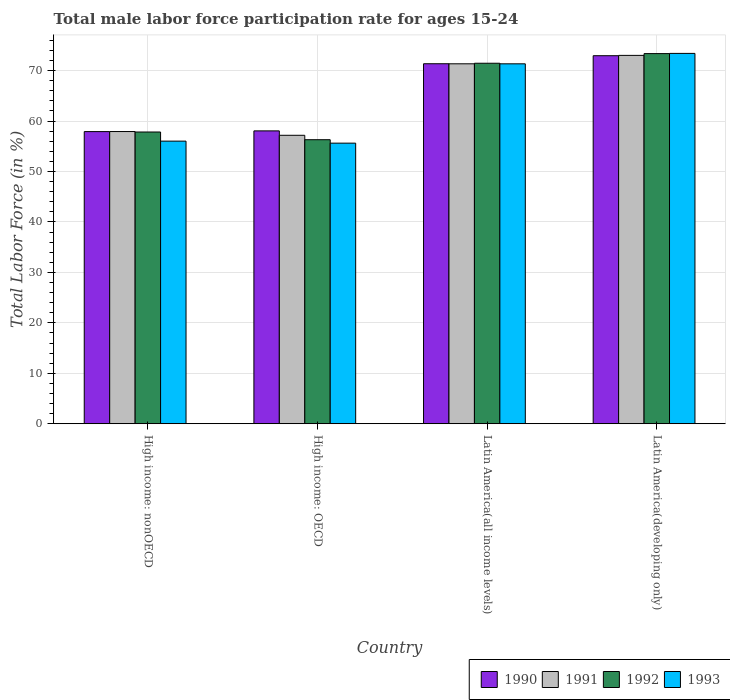Are the number of bars per tick equal to the number of legend labels?
Provide a succinct answer. Yes. How many bars are there on the 2nd tick from the left?
Give a very brief answer. 4. What is the label of the 3rd group of bars from the left?
Keep it short and to the point. Latin America(all income levels). What is the male labor force participation rate in 1990 in Latin America(developing only)?
Provide a succinct answer. 72.96. Across all countries, what is the maximum male labor force participation rate in 1990?
Provide a short and direct response. 72.96. Across all countries, what is the minimum male labor force participation rate in 1993?
Your answer should be compact. 55.62. In which country was the male labor force participation rate in 1990 maximum?
Offer a terse response. Latin America(developing only). In which country was the male labor force participation rate in 1992 minimum?
Make the answer very short. High income: OECD. What is the total male labor force participation rate in 1991 in the graph?
Offer a terse response. 259.48. What is the difference between the male labor force participation rate in 1990 in Latin America(all income levels) and that in Latin America(developing only)?
Provide a succinct answer. -1.59. What is the difference between the male labor force participation rate in 1991 in High income: nonOECD and the male labor force participation rate in 1992 in Latin America(developing only)?
Your answer should be compact. -15.45. What is the average male labor force participation rate in 1991 per country?
Give a very brief answer. 64.87. What is the difference between the male labor force participation rate of/in 1993 and male labor force participation rate of/in 1990 in High income: nonOECD?
Make the answer very short. -1.89. What is the ratio of the male labor force participation rate in 1990 in High income: OECD to that in Latin America(all income levels)?
Offer a terse response. 0.81. What is the difference between the highest and the second highest male labor force participation rate in 1990?
Keep it short and to the point. 14.9. What is the difference between the highest and the lowest male labor force participation rate in 1991?
Your response must be concise. 15.84. Is the sum of the male labor force participation rate in 1991 in Latin America(all income levels) and Latin America(developing only) greater than the maximum male labor force participation rate in 1990 across all countries?
Offer a terse response. Yes. Is it the case that in every country, the sum of the male labor force participation rate in 1993 and male labor force participation rate in 1992 is greater than the male labor force participation rate in 1991?
Offer a very short reply. Yes. How many bars are there?
Your answer should be compact. 16. Are all the bars in the graph horizontal?
Your answer should be compact. No. What is the difference between two consecutive major ticks on the Y-axis?
Your response must be concise. 10. Are the values on the major ticks of Y-axis written in scientific E-notation?
Ensure brevity in your answer.  No. Does the graph contain grids?
Provide a short and direct response. Yes. How many legend labels are there?
Your answer should be very brief. 4. How are the legend labels stacked?
Provide a short and direct response. Horizontal. What is the title of the graph?
Ensure brevity in your answer.  Total male labor force participation rate for ages 15-24. Does "1998" appear as one of the legend labels in the graph?
Offer a very short reply. No. What is the label or title of the X-axis?
Make the answer very short. Country. What is the Total Labor Force (in %) of 1990 in High income: nonOECD?
Your answer should be very brief. 57.91. What is the Total Labor Force (in %) of 1991 in High income: nonOECD?
Your answer should be compact. 57.92. What is the Total Labor Force (in %) in 1992 in High income: nonOECD?
Provide a short and direct response. 57.83. What is the Total Labor Force (in %) of 1993 in High income: nonOECD?
Offer a terse response. 56.02. What is the Total Labor Force (in %) of 1990 in High income: OECD?
Your answer should be very brief. 58.06. What is the Total Labor Force (in %) of 1991 in High income: OECD?
Provide a short and direct response. 57.18. What is the Total Labor Force (in %) of 1992 in High income: OECD?
Offer a very short reply. 56.31. What is the Total Labor Force (in %) of 1993 in High income: OECD?
Offer a terse response. 55.62. What is the Total Labor Force (in %) of 1990 in Latin America(all income levels)?
Your response must be concise. 71.36. What is the Total Labor Force (in %) in 1991 in Latin America(all income levels)?
Provide a short and direct response. 71.35. What is the Total Labor Force (in %) of 1992 in Latin America(all income levels)?
Make the answer very short. 71.46. What is the Total Labor Force (in %) of 1993 in Latin America(all income levels)?
Give a very brief answer. 71.35. What is the Total Labor Force (in %) in 1990 in Latin America(developing only)?
Keep it short and to the point. 72.96. What is the Total Labor Force (in %) of 1991 in Latin America(developing only)?
Your response must be concise. 73.02. What is the Total Labor Force (in %) in 1992 in Latin America(developing only)?
Make the answer very short. 73.38. What is the Total Labor Force (in %) of 1993 in Latin America(developing only)?
Your response must be concise. 73.42. Across all countries, what is the maximum Total Labor Force (in %) in 1990?
Ensure brevity in your answer.  72.96. Across all countries, what is the maximum Total Labor Force (in %) in 1991?
Offer a very short reply. 73.02. Across all countries, what is the maximum Total Labor Force (in %) in 1992?
Provide a succinct answer. 73.38. Across all countries, what is the maximum Total Labor Force (in %) in 1993?
Your answer should be very brief. 73.42. Across all countries, what is the minimum Total Labor Force (in %) in 1990?
Ensure brevity in your answer.  57.91. Across all countries, what is the minimum Total Labor Force (in %) in 1991?
Keep it short and to the point. 57.18. Across all countries, what is the minimum Total Labor Force (in %) in 1992?
Ensure brevity in your answer.  56.31. Across all countries, what is the minimum Total Labor Force (in %) in 1993?
Offer a terse response. 55.62. What is the total Total Labor Force (in %) of 1990 in the graph?
Provide a succinct answer. 260.29. What is the total Total Labor Force (in %) in 1991 in the graph?
Make the answer very short. 259.48. What is the total Total Labor Force (in %) in 1992 in the graph?
Make the answer very short. 258.98. What is the total Total Labor Force (in %) of 1993 in the graph?
Give a very brief answer. 256.41. What is the difference between the Total Labor Force (in %) of 1990 in High income: nonOECD and that in High income: OECD?
Make the answer very short. -0.14. What is the difference between the Total Labor Force (in %) of 1991 in High income: nonOECD and that in High income: OECD?
Your answer should be very brief. 0.74. What is the difference between the Total Labor Force (in %) of 1992 in High income: nonOECD and that in High income: OECD?
Your response must be concise. 1.53. What is the difference between the Total Labor Force (in %) of 1993 in High income: nonOECD and that in High income: OECD?
Your answer should be compact. 0.4. What is the difference between the Total Labor Force (in %) of 1990 in High income: nonOECD and that in Latin America(all income levels)?
Offer a very short reply. -13.45. What is the difference between the Total Labor Force (in %) of 1991 in High income: nonOECD and that in Latin America(all income levels)?
Your answer should be very brief. -13.43. What is the difference between the Total Labor Force (in %) in 1992 in High income: nonOECD and that in Latin America(all income levels)?
Your answer should be compact. -13.63. What is the difference between the Total Labor Force (in %) of 1993 in High income: nonOECD and that in Latin America(all income levels)?
Your answer should be compact. -15.33. What is the difference between the Total Labor Force (in %) in 1990 in High income: nonOECD and that in Latin America(developing only)?
Provide a short and direct response. -15.05. What is the difference between the Total Labor Force (in %) in 1991 in High income: nonOECD and that in Latin America(developing only)?
Keep it short and to the point. -15.1. What is the difference between the Total Labor Force (in %) in 1992 in High income: nonOECD and that in Latin America(developing only)?
Your answer should be compact. -15.54. What is the difference between the Total Labor Force (in %) of 1993 in High income: nonOECD and that in Latin America(developing only)?
Provide a succinct answer. -17.39. What is the difference between the Total Labor Force (in %) in 1990 in High income: OECD and that in Latin America(all income levels)?
Offer a terse response. -13.31. What is the difference between the Total Labor Force (in %) in 1991 in High income: OECD and that in Latin America(all income levels)?
Give a very brief answer. -14.17. What is the difference between the Total Labor Force (in %) of 1992 in High income: OECD and that in Latin America(all income levels)?
Give a very brief answer. -15.16. What is the difference between the Total Labor Force (in %) of 1993 in High income: OECD and that in Latin America(all income levels)?
Your answer should be compact. -15.73. What is the difference between the Total Labor Force (in %) of 1990 in High income: OECD and that in Latin America(developing only)?
Give a very brief answer. -14.9. What is the difference between the Total Labor Force (in %) in 1991 in High income: OECD and that in Latin America(developing only)?
Your response must be concise. -15.84. What is the difference between the Total Labor Force (in %) in 1992 in High income: OECD and that in Latin America(developing only)?
Your response must be concise. -17.07. What is the difference between the Total Labor Force (in %) in 1993 in High income: OECD and that in Latin America(developing only)?
Provide a short and direct response. -17.79. What is the difference between the Total Labor Force (in %) of 1990 in Latin America(all income levels) and that in Latin America(developing only)?
Your answer should be very brief. -1.59. What is the difference between the Total Labor Force (in %) in 1991 in Latin America(all income levels) and that in Latin America(developing only)?
Keep it short and to the point. -1.67. What is the difference between the Total Labor Force (in %) in 1992 in Latin America(all income levels) and that in Latin America(developing only)?
Provide a succinct answer. -1.91. What is the difference between the Total Labor Force (in %) of 1993 in Latin America(all income levels) and that in Latin America(developing only)?
Give a very brief answer. -2.07. What is the difference between the Total Labor Force (in %) of 1990 in High income: nonOECD and the Total Labor Force (in %) of 1991 in High income: OECD?
Provide a succinct answer. 0.73. What is the difference between the Total Labor Force (in %) of 1990 in High income: nonOECD and the Total Labor Force (in %) of 1992 in High income: OECD?
Provide a short and direct response. 1.61. What is the difference between the Total Labor Force (in %) in 1990 in High income: nonOECD and the Total Labor Force (in %) in 1993 in High income: OECD?
Keep it short and to the point. 2.29. What is the difference between the Total Labor Force (in %) in 1991 in High income: nonOECD and the Total Labor Force (in %) in 1992 in High income: OECD?
Offer a terse response. 1.62. What is the difference between the Total Labor Force (in %) of 1991 in High income: nonOECD and the Total Labor Force (in %) of 1993 in High income: OECD?
Your answer should be compact. 2.3. What is the difference between the Total Labor Force (in %) of 1992 in High income: nonOECD and the Total Labor Force (in %) of 1993 in High income: OECD?
Your answer should be very brief. 2.21. What is the difference between the Total Labor Force (in %) in 1990 in High income: nonOECD and the Total Labor Force (in %) in 1991 in Latin America(all income levels)?
Make the answer very short. -13.44. What is the difference between the Total Labor Force (in %) in 1990 in High income: nonOECD and the Total Labor Force (in %) in 1992 in Latin America(all income levels)?
Give a very brief answer. -13.55. What is the difference between the Total Labor Force (in %) in 1990 in High income: nonOECD and the Total Labor Force (in %) in 1993 in Latin America(all income levels)?
Your answer should be very brief. -13.44. What is the difference between the Total Labor Force (in %) of 1991 in High income: nonOECD and the Total Labor Force (in %) of 1992 in Latin America(all income levels)?
Your answer should be compact. -13.54. What is the difference between the Total Labor Force (in %) of 1991 in High income: nonOECD and the Total Labor Force (in %) of 1993 in Latin America(all income levels)?
Your answer should be very brief. -13.43. What is the difference between the Total Labor Force (in %) of 1992 in High income: nonOECD and the Total Labor Force (in %) of 1993 in Latin America(all income levels)?
Your response must be concise. -13.52. What is the difference between the Total Labor Force (in %) of 1990 in High income: nonOECD and the Total Labor Force (in %) of 1991 in Latin America(developing only)?
Make the answer very short. -15.11. What is the difference between the Total Labor Force (in %) in 1990 in High income: nonOECD and the Total Labor Force (in %) in 1992 in Latin America(developing only)?
Provide a succinct answer. -15.46. What is the difference between the Total Labor Force (in %) of 1990 in High income: nonOECD and the Total Labor Force (in %) of 1993 in Latin America(developing only)?
Ensure brevity in your answer.  -15.5. What is the difference between the Total Labor Force (in %) in 1991 in High income: nonOECD and the Total Labor Force (in %) in 1992 in Latin America(developing only)?
Offer a very short reply. -15.45. What is the difference between the Total Labor Force (in %) in 1991 in High income: nonOECD and the Total Labor Force (in %) in 1993 in Latin America(developing only)?
Provide a short and direct response. -15.49. What is the difference between the Total Labor Force (in %) in 1992 in High income: nonOECD and the Total Labor Force (in %) in 1993 in Latin America(developing only)?
Ensure brevity in your answer.  -15.59. What is the difference between the Total Labor Force (in %) of 1990 in High income: OECD and the Total Labor Force (in %) of 1991 in Latin America(all income levels)?
Provide a succinct answer. -13.3. What is the difference between the Total Labor Force (in %) in 1990 in High income: OECD and the Total Labor Force (in %) in 1992 in Latin America(all income levels)?
Ensure brevity in your answer.  -13.41. What is the difference between the Total Labor Force (in %) of 1990 in High income: OECD and the Total Labor Force (in %) of 1993 in Latin America(all income levels)?
Offer a very short reply. -13.29. What is the difference between the Total Labor Force (in %) of 1991 in High income: OECD and the Total Labor Force (in %) of 1992 in Latin America(all income levels)?
Make the answer very short. -14.28. What is the difference between the Total Labor Force (in %) in 1991 in High income: OECD and the Total Labor Force (in %) in 1993 in Latin America(all income levels)?
Provide a succinct answer. -14.17. What is the difference between the Total Labor Force (in %) of 1992 in High income: OECD and the Total Labor Force (in %) of 1993 in Latin America(all income levels)?
Offer a terse response. -15.04. What is the difference between the Total Labor Force (in %) in 1990 in High income: OECD and the Total Labor Force (in %) in 1991 in Latin America(developing only)?
Your response must be concise. -14.97. What is the difference between the Total Labor Force (in %) in 1990 in High income: OECD and the Total Labor Force (in %) in 1992 in Latin America(developing only)?
Provide a succinct answer. -15.32. What is the difference between the Total Labor Force (in %) of 1990 in High income: OECD and the Total Labor Force (in %) of 1993 in Latin America(developing only)?
Offer a terse response. -15.36. What is the difference between the Total Labor Force (in %) of 1991 in High income: OECD and the Total Labor Force (in %) of 1992 in Latin America(developing only)?
Your response must be concise. -16.19. What is the difference between the Total Labor Force (in %) in 1991 in High income: OECD and the Total Labor Force (in %) in 1993 in Latin America(developing only)?
Provide a short and direct response. -16.23. What is the difference between the Total Labor Force (in %) of 1992 in High income: OECD and the Total Labor Force (in %) of 1993 in Latin America(developing only)?
Provide a short and direct response. -17.11. What is the difference between the Total Labor Force (in %) of 1990 in Latin America(all income levels) and the Total Labor Force (in %) of 1991 in Latin America(developing only)?
Ensure brevity in your answer.  -1.66. What is the difference between the Total Labor Force (in %) in 1990 in Latin America(all income levels) and the Total Labor Force (in %) in 1992 in Latin America(developing only)?
Offer a very short reply. -2.01. What is the difference between the Total Labor Force (in %) of 1990 in Latin America(all income levels) and the Total Labor Force (in %) of 1993 in Latin America(developing only)?
Your answer should be very brief. -2.05. What is the difference between the Total Labor Force (in %) of 1991 in Latin America(all income levels) and the Total Labor Force (in %) of 1992 in Latin America(developing only)?
Make the answer very short. -2.02. What is the difference between the Total Labor Force (in %) in 1991 in Latin America(all income levels) and the Total Labor Force (in %) in 1993 in Latin America(developing only)?
Provide a short and direct response. -2.06. What is the difference between the Total Labor Force (in %) of 1992 in Latin America(all income levels) and the Total Labor Force (in %) of 1993 in Latin America(developing only)?
Offer a very short reply. -1.95. What is the average Total Labor Force (in %) in 1990 per country?
Offer a terse response. 65.07. What is the average Total Labor Force (in %) in 1991 per country?
Your response must be concise. 64.87. What is the average Total Labor Force (in %) of 1992 per country?
Offer a terse response. 64.74. What is the average Total Labor Force (in %) in 1993 per country?
Keep it short and to the point. 64.1. What is the difference between the Total Labor Force (in %) of 1990 and Total Labor Force (in %) of 1991 in High income: nonOECD?
Your answer should be compact. -0.01. What is the difference between the Total Labor Force (in %) in 1990 and Total Labor Force (in %) in 1992 in High income: nonOECD?
Provide a short and direct response. 0.08. What is the difference between the Total Labor Force (in %) of 1990 and Total Labor Force (in %) of 1993 in High income: nonOECD?
Keep it short and to the point. 1.89. What is the difference between the Total Labor Force (in %) in 1991 and Total Labor Force (in %) in 1992 in High income: nonOECD?
Give a very brief answer. 0.09. What is the difference between the Total Labor Force (in %) in 1991 and Total Labor Force (in %) in 1993 in High income: nonOECD?
Provide a short and direct response. 1.9. What is the difference between the Total Labor Force (in %) of 1992 and Total Labor Force (in %) of 1993 in High income: nonOECD?
Provide a short and direct response. 1.81. What is the difference between the Total Labor Force (in %) in 1990 and Total Labor Force (in %) in 1991 in High income: OECD?
Your response must be concise. 0.87. What is the difference between the Total Labor Force (in %) of 1990 and Total Labor Force (in %) of 1992 in High income: OECD?
Your answer should be compact. 1.75. What is the difference between the Total Labor Force (in %) of 1990 and Total Labor Force (in %) of 1993 in High income: OECD?
Provide a short and direct response. 2.43. What is the difference between the Total Labor Force (in %) in 1991 and Total Labor Force (in %) in 1992 in High income: OECD?
Provide a succinct answer. 0.88. What is the difference between the Total Labor Force (in %) in 1991 and Total Labor Force (in %) in 1993 in High income: OECD?
Give a very brief answer. 1.56. What is the difference between the Total Labor Force (in %) in 1992 and Total Labor Force (in %) in 1993 in High income: OECD?
Make the answer very short. 0.68. What is the difference between the Total Labor Force (in %) of 1990 and Total Labor Force (in %) of 1991 in Latin America(all income levels)?
Provide a short and direct response. 0.01. What is the difference between the Total Labor Force (in %) in 1990 and Total Labor Force (in %) in 1992 in Latin America(all income levels)?
Provide a succinct answer. -0.1. What is the difference between the Total Labor Force (in %) of 1990 and Total Labor Force (in %) of 1993 in Latin America(all income levels)?
Your response must be concise. 0.02. What is the difference between the Total Labor Force (in %) of 1991 and Total Labor Force (in %) of 1992 in Latin America(all income levels)?
Offer a terse response. -0.11. What is the difference between the Total Labor Force (in %) in 1991 and Total Labor Force (in %) in 1993 in Latin America(all income levels)?
Your response must be concise. 0. What is the difference between the Total Labor Force (in %) of 1992 and Total Labor Force (in %) of 1993 in Latin America(all income levels)?
Your response must be concise. 0.11. What is the difference between the Total Labor Force (in %) of 1990 and Total Labor Force (in %) of 1991 in Latin America(developing only)?
Ensure brevity in your answer.  -0.07. What is the difference between the Total Labor Force (in %) in 1990 and Total Labor Force (in %) in 1992 in Latin America(developing only)?
Offer a terse response. -0.42. What is the difference between the Total Labor Force (in %) in 1990 and Total Labor Force (in %) in 1993 in Latin America(developing only)?
Offer a very short reply. -0.46. What is the difference between the Total Labor Force (in %) in 1991 and Total Labor Force (in %) in 1992 in Latin America(developing only)?
Offer a very short reply. -0.35. What is the difference between the Total Labor Force (in %) in 1991 and Total Labor Force (in %) in 1993 in Latin America(developing only)?
Ensure brevity in your answer.  -0.39. What is the difference between the Total Labor Force (in %) in 1992 and Total Labor Force (in %) in 1993 in Latin America(developing only)?
Your answer should be compact. -0.04. What is the ratio of the Total Labor Force (in %) in 1991 in High income: nonOECD to that in High income: OECD?
Provide a succinct answer. 1.01. What is the ratio of the Total Labor Force (in %) of 1992 in High income: nonOECD to that in High income: OECD?
Your response must be concise. 1.03. What is the ratio of the Total Labor Force (in %) of 1993 in High income: nonOECD to that in High income: OECD?
Offer a very short reply. 1.01. What is the ratio of the Total Labor Force (in %) in 1990 in High income: nonOECD to that in Latin America(all income levels)?
Give a very brief answer. 0.81. What is the ratio of the Total Labor Force (in %) of 1991 in High income: nonOECD to that in Latin America(all income levels)?
Make the answer very short. 0.81. What is the ratio of the Total Labor Force (in %) of 1992 in High income: nonOECD to that in Latin America(all income levels)?
Give a very brief answer. 0.81. What is the ratio of the Total Labor Force (in %) of 1993 in High income: nonOECD to that in Latin America(all income levels)?
Provide a short and direct response. 0.79. What is the ratio of the Total Labor Force (in %) of 1990 in High income: nonOECD to that in Latin America(developing only)?
Offer a terse response. 0.79. What is the ratio of the Total Labor Force (in %) of 1991 in High income: nonOECD to that in Latin America(developing only)?
Provide a succinct answer. 0.79. What is the ratio of the Total Labor Force (in %) of 1992 in High income: nonOECD to that in Latin America(developing only)?
Keep it short and to the point. 0.79. What is the ratio of the Total Labor Force (in %) of 1993 in High income: nonOECD to that in Latin America(developing only)?
Provide a succinct answer. 0.76. What is the ratio of the Total Labor Force (in %) of 1990 in High income: OECD to that in Latin America(all income levels)?
Keep it short and to the point. 0.81. What is the ratio of the Total Labor Force (in %) of 1991 in High income: OECD to that in Latin America(all income levels)?
Keep it short and to the point. 0.8. What is the ratio of the Total Labor Force (in %) of 1992 in High income: OECD to that in Latin America(all income levels)?
Keep it short and to the point. 0.79. What is the ratio of the Total Labor Force (in %) in 1993 in High income: OECD to that in Latin America(all income levels)?
Give a very brief answer. 0.78. What is the ratio of the Total Labor Force (in %) in 1990 in High income: OECD to that in Latin America(developing only)?
Your response must be concise. 0.8. What is the ratio of the Total Labor Force (in %) of 1991 in High income: OECD to that in Latin America(developing only)?
Your answer should be compact. 0.78. What is the ratio of the Total Labor Force (in %) in 1992 in High income: OECD to that in Latin America(developing only)?
Your response must be concise. 0.77. What is the ratio of the Total Labor Force (in %) in 1993 in High income: OECD to that in Latin America(developing only)?
Give a very brief answer. 0.76. What is the ratio of the Total Labor Force (in %) in 1990 in Latin America(all income levels) to that in Latin America(developing only)?
Your answer should be very brief. 0.98. What is the ratio of the Total Labor Force (in %) in 1991 in Latin America(all income levels) to that in Latin America(developing only)?
Provide a short and direct response. 0.98. What is the ratio of the Total Labor Force (in %) of 1992 in Latin America(all income levels) to that in Latin America(developing only)?
Give a very brief answer. 0.97. What is the ratio of the Total Labor Force (in %) of 1993 in Latin America(all income levels) to that in Latin America(developing only)?
Offer a very short reply. 0.97. What is the difference between the highest and the second highest Total Labor Force (in %) of 1990?
Keep it short and to the point. 1.59. What is the difference between the highest and the second highest Total Labor Force (in %) in 1991?
Give a very brief answer. 1.67. What is the difference between the highest and the second highest Total Labor Force (in %) of 1992?
Your response must be concise. 1.91. What is the difference between the highest and the second highest Total Labor Force (in %) of 1993?
Keep it short and to the point. 2.07. What is the difference between the highest and the lowest Total Labor Force (in %) of 1990?
Provide a short and direct response. 15.05. What is the difference between the highest and the lowest Total Labor Force (in %) of 1991?
Offer a terse response. 15.84. What is the difference between the highest and the lowest Total Labor Force (in %) of 1992?
Your answer should be compact. 17.07. What is the difference between the highest and the lowest Total Labor Force (in %) of 1993?
Provide a short and direct response. 17.79. 